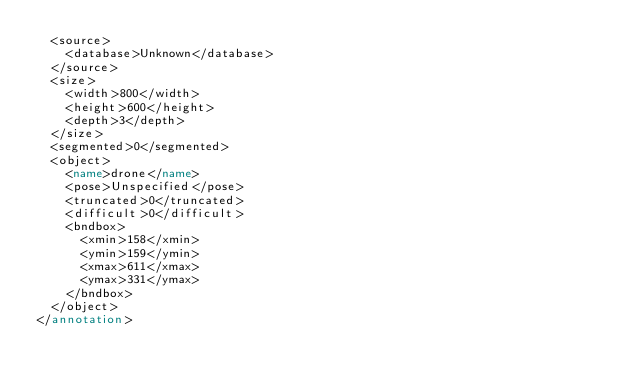Convert code to text. <code><loc_0><loc_0><loc_500><loc_500><_XML_>	<source>
		<database>Unknown</database>
	</source>
	<size>
		<width>800</width>
		<height>600</height>
		<depth>3</depth>
	</size>
	<segmented>0</segmented>
	<object>
		<name>drone</name>
		<pose>Unspecified</pose>
		<truncated>0</truncated>
		<difficult>0</difficult>
		<bndbox>
			<xmin>158</xmin>
			<ymin>159</ymin>
			<xmax>611</xmax>
			<ymax>331</ymax>
		</bndbox>
	</object>
</annotation>
</code> 